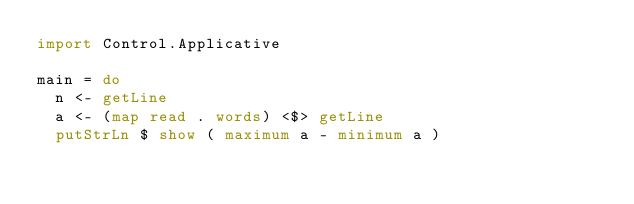<code> <loc_0><loc_0><loc_500><loc_500><_Haskell_>import Control.Applicative

main = do
  n <- getLine
  a <- (map read . words) <$> getLine
  putStrLn $ show ( maximum a - minimum a )</code> 